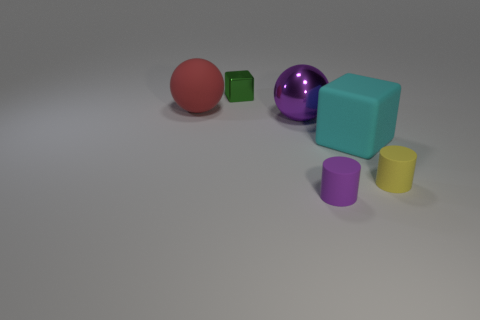Add 3 big green objects. How many objects exist? 9 Subtract all cylinders. How many objects are left? 4 Subtract 1 cylinders. How many cylinders are left? 1 Add 6 tiny yellow things. How many tiny yellow things are left? 7 Add 4 big cyan cubes. How many big cyan cubes exist? 5 Subtract 1 yellow cylinders. How many objects are left? 5 Subtract all red balls. Subtract all purple cylinders. How many balls are left? 1 Subtract all rubber cylinders. Subtract all tiny purple objects. How many objects are left? 3 